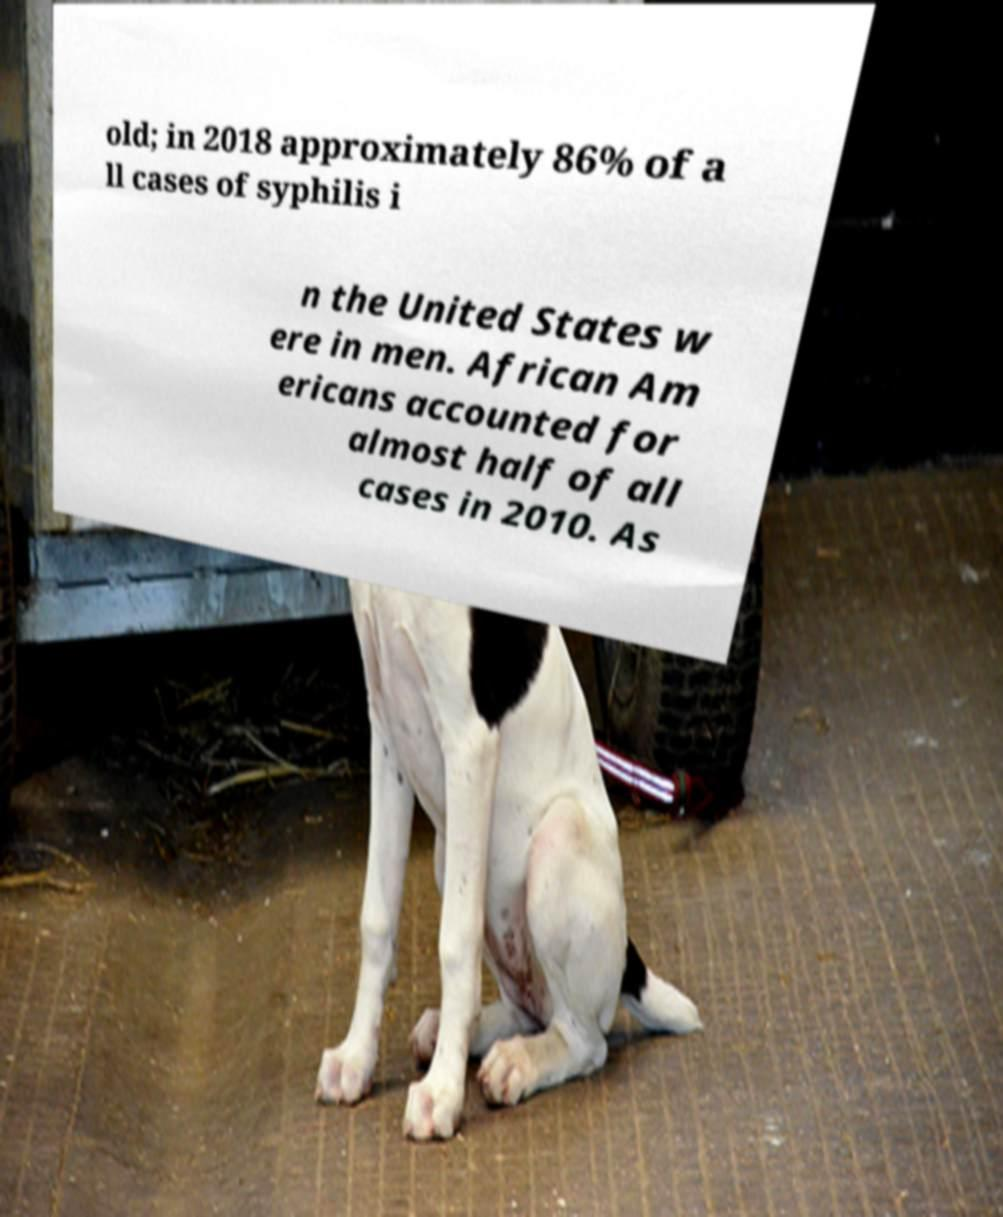Can you accurately transcribe the text from the provided image for me? old; in 2018 approximately 86% of a ll cases of syphilis i n the United States w ere in men. African Am ericans accounted for almost half of all cases in 2010. As 